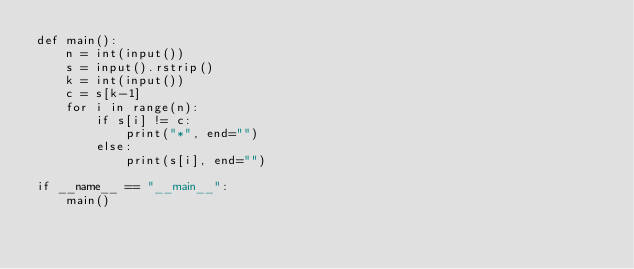<code> <loc_0><loc_0><loc_500><loc_500><_Python_>def main():
    n = int(input())
    s = input().rstrip()
    k = int(input())
    c = s[k-1]
    for i in range(n):
        if s[i] != c:
            print("*", end="")
        else:
            print(s[i], end="")

if __name__ == "__main__":
    main()</code> 